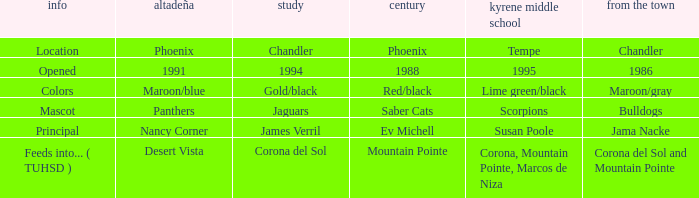Parse the full table. {'header': ['info', 'altadeña', 'study', 'century', 'kyrene middle school', 'from the town'], 'rows': [['Location', 'Phoenix', 'Chandler', 'Phoenix', 'Tempe', 'Chandler'], ['Opened', '1991', '1994', '1988', '1995', '1986'], ['Colors', 'Maroon/blue', 'Gold/black', 'Red/black', 'Lime green/black', 'Maroon/gray'], ['Mascot', 'Panthers', 'Jaguars', 'Saber Cats', 'Scorpions', 'Bulldogs'], ['Principal', 'Nancy Corner', 'James Verril', 'Ev Michell', 'Susan Poole', 'Jama Nacke'], ['Feeds into... ( TUHSD )', 'Desert Vista', 'Corona del Sol', 'Mountain Pointe', 'Corona, Mountain Pointe, Marcos de Niza', 'Corona del Sol and Mountain Pointe']]} What kind of Altadeña has del Pueblo of maroon/gray? Maroon/blue. 